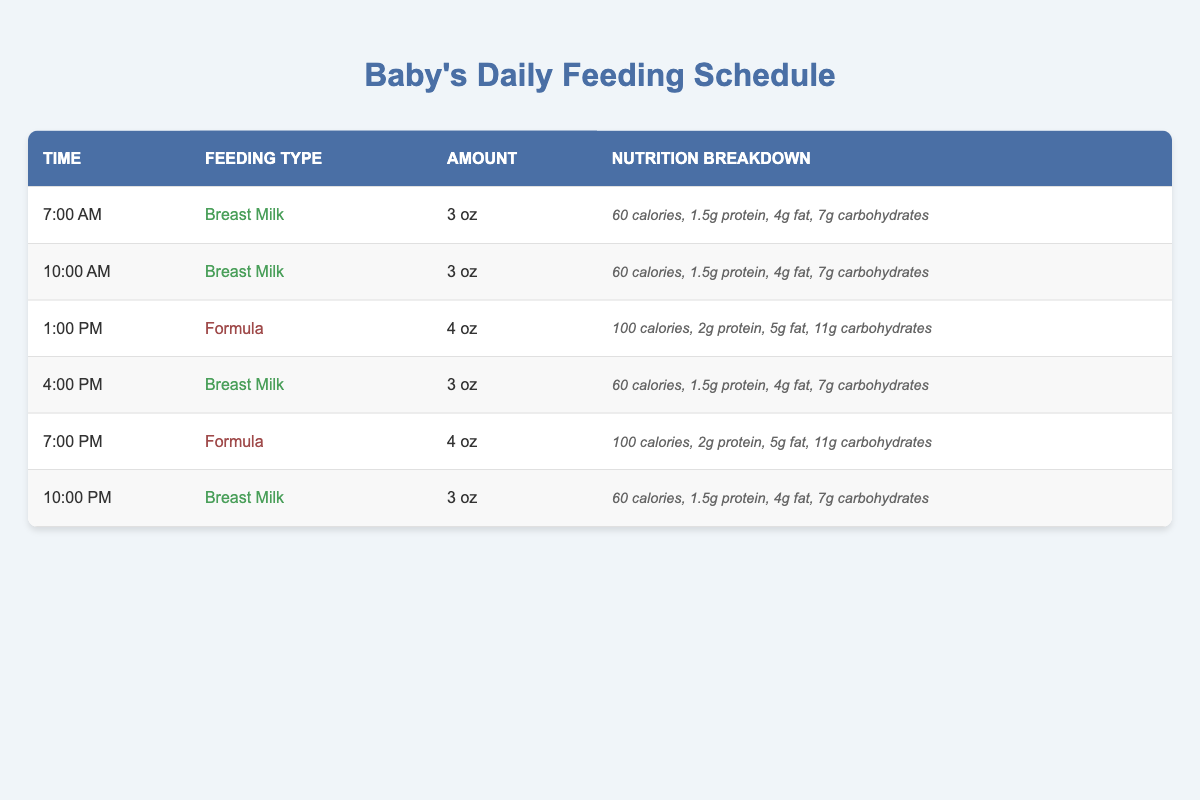What type of feeding is given at 1:00 PM? The table specifies that the feeding type is indicated in the second column for each time entry. At 1:00 PM, the feeding type is listed as "Formula."
Answer: Formula How many ounces of Breast Milk are given at 7:00 AM? The table shows the amount of each feeding type in the third column. At 7:00 AM, the amount is recorded as "3 oz" for Breast Milk.
Answer: 3 oz What is the total caloric intake from all feedings at 10:00 AM? At 10:00 AM, the feeding is Breast Milk, which provides 60 calories. According to the table, there are no additional feedings at that specific time, so the total caloric intake is just 60 calories.
Answer: 60 calories Does the 4:00 PM feeding have more fat than the 1:00 PM feeding? The nutrition breakdown for the 4:00 PM feeding of Breast Milk has 4 g of fat, while the 1:00 PM feeding of Formula has 5 g of fat. Since 4 g is less than 5 g, the statement is false.
Answer: No What is the average amount of protein from all feedings? The feedings provide the following protein amounts: 1.5 g (Breast Milk), 1.5 g (Breast Milk), 2 g (Formula), 1.5 g (Breast Milk), 2 g (Formula), and 1.5 g (Breast Milk). Summing these gives 10 g total. With 6 feedings, the average is 10 g / 6 = 1.67 g.
Answer: 1.67 g Which feeding type has higher total calories during the day? To find total calories, we can sum the calories for each feeding type: Breast Milk (60 + 60 + 60 + 60 = 240 calories) and Formula (100 + 100 = 200 calories). Since 240 calories (Breast Milk) is greater than 200 calories (Formula), we conclude that Breast Milk has higher total calories.
Answer: Breast Milk What is the total amount of carbohydrates consumed from all feedings? The carbohydrates for each feeding are as follows: 7 g (Breast Milk), 7 g (Breast Milk), 11 g (Formula), 7 g (Breast Milk), 11 g (Formula), and 7 g (Breast Milk). Summing these gives 60 g total carbohydrates consumed throughout the day.
Answer: 60 g At what times is breast milk fed? The times indicated for Breast Milk in the second column are 7:00 AM, 10:00 AM, 4:00 PM, and 10:00 PM. This shows that Breast Milk is fed at these times based on the schedule outlined in the table.
Answer: 7:00 AM, 10:00 AM, 4:00 PM, 10:00 PM Is the feeding type consistent throughout the morning? In the table, during the morning, there are two feedings at 7:00 AM and 10:00 AM, both of which are Breast Milk. Therefore, the feeding type is consistent in the morning.
Answer: Yes How much more fat does a 4 oz Formula feeding have compared to a 3 oz Breast Milk feeding? The 4 oz Formula has 5 g of fat, whereas the 3 oz Breast Milk has 4 g of fat. The difference is 5 g - 4 g = 1 g. Therefore, the Formula feeding has 1 g more fat.
Answer: 1 g more fat What is the total volume of feeds provided in a day? To find the total volume, we add the amounts of all feedings: 3 oz (7:00 AM) + 3 oz (10:00 AM) + 4 oz (1:00 PM) + 3 oz (4:00 PM) + 4 oz (7:00 PM) + 3 oz (10:00 PM) = 20 oz total.
Answer: 20 oz 